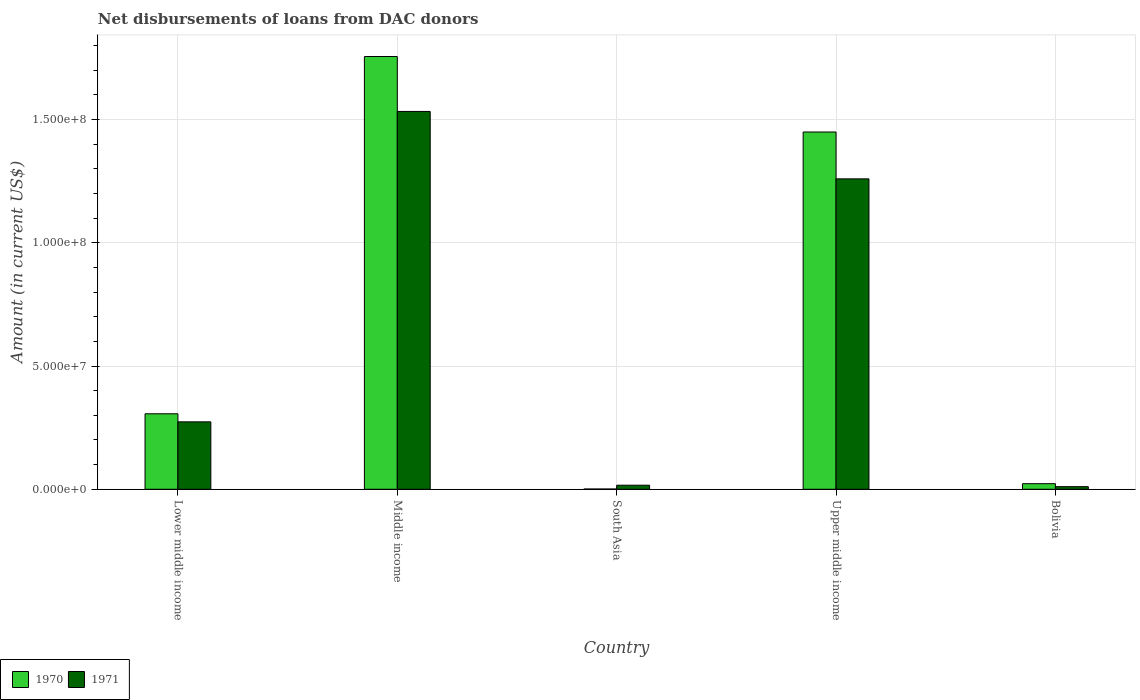How many different coloured bars are there?
Offer a terse response. 2. How many groups of bars are there?
Provide a succinct answer. 5. Are the number of bars per tick equal to the number of legend labels?
Your answer should be very brief. Yes. Are the number of bars on each tick of the X-axis equal?
Keep it short and to the point. Yes. What is the label of the 3rd group of bars from the left?
Provide a succinct answer. South Asia. What is the amount of loans disbursed in 1971 in Upper middle income?
Offer a very short reply. 1.26e+08. Across all countries, what is the maximum amount of loans disbursed in 1970?
Your answer should be compact. 1.76e+08. Across all countries, what is the minimum amount of loans disbursed in 1971?
Offer a very short reply. 1.06e+06. In which country was the amount of loans disbursed in 1970 minimum?
Your answer should be compact. South Asia. What is the total amount of loans disbursed in 1971 in the graph?
Keep it short and to the point. 3.09e+08. What is the difference between the amount of loans disbursed in 1971 in Bolivia and that in South Asia?
Make the answer very short. -5.92e+05. What is the difference between the amount of loans disbursed in 1970 in Lower middle income and the amount of loans disbursed in 1971 in Bolivia?
Your response must be concise. 2.96e+07. What is the average amount of loans disbursed in 1970 per country?
Make the answer very short. 7.07e+07. What is the difference between the amount of loans disbursed of/in 1971 and amount of loans disbursed of/in 1970 in Upper middle income?
Your answer should be compact. -1.90e+07. What is the ratio of the amount of loans disbursed in 1970 in Lower middle income to that in Upper middle income?
Provide a short and direct response. 0.21. Is the amount of loans disbursed in 1970 in Bolivia less than that in South Asia?
Your answer should be very brief. No. Is the difference between the amount of loans disbursed in 1971 in Middle income and South Asia greater than the difference between the amount of loans disbursed in 1970 in Middle income and South Asia?
Give a very brief answer. No. What is the difference between the highest and the second highest amount of loans disbursed in 1971?
Your answer should be very brief. 1.26e+08. What is the difference between the highest and the lowest amount of loans disbursed in 1970?
Your response must be concise. 1.75e+08. In how many countries, is the amount of loans disbursed in 1971 greater than the average amount of loans disbursed in 1971 taken over all countries?
Offer a very short reply. 2. What does the 2nd bar from the right in Middle income represents?
Your response must be concise. 1970. How many bars are there?
Your answer should be compact. 10. What is the difference between two consecutive major ticks on the Y-axis?
Your response must be concise. 5.00e+07. Does the graph contain any zero values?
Keep it short and to the point. No. Does the graph contain grids?
Provide a succinct answer. Yes. How many legend labels are there?
Give a very brief answer. 2. How are the legend labels stacked?
Provide a short and direct response. Horizontal. What is the title of the graph?
Make the answer very short. Net disbursements of loans from DAC donors. What is the label or title of the Y-axis?
Ensure brevity in your answer.  Amount (in current US$). What is the Amount (in current US$) of 1970 in Lower middle income?
Your response must be concise. 3.06e+07. What is the Amount (in current US$) in 1971 in Lower middle income?
Your response must be concise. 2.74e+07. What is the Amount (in current US$) of 1970 in Middle income?
Ensure brevity in your answer.  1.76e+08. What is the Amount (in current US$) of 1971 in Middle income?
Keep it short and to the point. 1.53e+08. What is the Amount (in current US$) of 1970 in South Asia?
Provide a succinct answer. 1.09e+05. What is the Amount (in current US$) of 1971 in South Asia?
Give a very brief answer. 1.65e+06. What is the Amount (in current US$) in 1970 in Upper middle income?
Provide a short and direct response. 1.45e+08. What is the Amount (in current US$) in 1971 in Upper middle income?
Give a very brief answer. 1.26e+08. What is the Amount (in current US$) in 1970 in Bolivia?
Provide a short and direct response. 2.27e+06. What is the Amount (in current US$) in 1971 in Bolivia?
Make the answer very short. 1.06e+06. Across all countries, what is the maximum Amount (in current US$) in 1970?
Offer a very short reply. 1.76e+08. Across all countries, what is the maximum Amount (in current US$) of 1971?
Your answer should be compact. 1.53e+08. Across all countries, what is the minimum Amount (in current US$) in 1970?
Provide a succinct answer. 1.09e+05. Across all countries, what is the minimum Amount (in current US$) in 1971?
Provide a succinct answer. 1.06e+06. What is the total Amount (in current US$) of 1970 in the graph?
Offer a terse response. 3.53e+08. What is the total Amount (in current US$) in 1971 in the graph?
Offer a terse response. 3.09e+08. What is the difference between the Amount (in current US$) of 1970 in Lower middle income and that in Middle income?
Provide a succinct answer. -1.45e+08. What is the difference between the Amount (in current US$) in 1971 in Lower middle income and that in Middle income?
Make the answer very short. -1.26e+08. What is the difference between the Amount (in current US$) in 1970 in Lower middle income and that in South Asia?
Offer a terse response. 3.05e+07. What is the difference between the Amount (in current US$) of 1971 in Lower middle income and that in South Asia?
Your answer should be compact. 2.57e+07. What is the difference between the Amount (in current US$) of 1970 in Lower middle income and that in Upper middle income?
Give a very brief answer. -1.14e+08. What is the difference between the Amount (in current US$) of 1971 in Lower middle income and that in Upper middle income?
Offer a very short reply. -9.86e+07. What is the difference between the Amount (in current US$) in 1970 in Lower middle income and that in Bolivia?
Offer a very short reply. 2.84e+07. What is the difference between the Amount (in current US$) in 1971 in Lower middle income and that in Bolivia?
Your answer should be very brief. 2.63e+07. What is the difference between the Amount (in current US$) of 1970 in Middle income and that in South Asia?
Ensure brevity in your answer.  1.75e+08. What is the difference between the Amount (in current US$) of 1971 in Middle income and that in South Asia?
Offer a very short reply. 1.52e+08. What is the difference between the Amount (in current US$) in 1970 in Middle income and that in Upper middle income?
Provide a short and direct response. 3.06e+07. What is the difference between the Amount (in current US$) in 1971 in Middle income and that in Upper middle income?
Your response must be concise. 2.74e+07. What is the difference between the Amount (in current US$) in 1970 in Middle income and that in Bolivia?
Keep it short and to the point. 1.73e+08. What is the difference between the Amount (in current US$) of 1971 in Middle income and that in Bolivia?
Provide a succinct answer. 1.52e+08. What is the difference between the Amount (in current US$) in 1970 in South Asia and that in Upper middle income?
Provide a succinct answer. -1.45e+08. What is the difference between the Amount (in current US$) in 1971 in South Asia and that in Upper middle income?
Give a very brief answer. -1.24e+08. What is the difference between the Amount (in current US$) in 1970 in South Asia and that in Bolivia?
Your response must be concise. -2.16e+06. What is the difference between the Amount (in current US$) in 1971 in South Asia and that in Bolivia?
Your answer should be very brief. 5.92e+05. What is the difference between the Amount (in current US$) of 1970 in Upper middle income and that in Bolivia?
Your response must be concise. 1.43e+08. What is the difference between the Amount (in current US$) in 1971 in Upper middle income and that in Bolivia?
Offer a very short reply. 1.25e+08. What is the difference between the Amount (in current US$) of 1970 in Lower middle income and the Amount (in current US$) of 1971 in Middle income?
Offer a very short reply. -1.23e+08. What is the difference between the Amount (in current US$) in 1970 in Lower middle income and the Amount (in current US$) in 1971 in South Asia?
Your response must be concise. 2.90e+07. What is the difference between the Amount (in current US$) of 1970 in Lower middle income and the Amount (in current US$) of 1971 in Upper middle income?
Keep it short and to the point. -9.53e+07. What is the difference between the Amount (in current US$) of 1970 in Lower middle income and the Amount (in current US$) of 1971 in Bolivia?
Provide a succinct answer. 2.96e+07. What is the difference between the Amount (in current US$) in 1970 in Middle income and the Amount (in current US$) in 1971 in South Asia?
Give a very brief answer. 1.74e+08. What is the difference between the Amount (in current US$) of 1970 in Middle income and the Amount (in current US$) of 1971 in Upper middle income?
Ensure brevity in your answer.  4.96e+07. What is the difference between the Amount (in current US$) in 1970 in Middle income and the Amount (in current US$) in 1971 in Bolivia?
Your answer should be very brief. 1.74e+08. What is the difference between the Amount (in current US$) of 1970 in South Asia and the Amount (in current US$) of 1971 in Upper middle income?
Your response must be concise. -1.26e+08. What is the difference between the Amount (in current US$) of 1970 in South Asia and the Amount (in current US$) of 1971 in Bolivia?
Provide a succinct answer. -9.49e+05. What is the difference between the Amount (in current US$) in 1970 in Upper middle income and the Amount (in current US$) in 1971 in Bolivia?
Offer a terse response. 1.44e+08. What is the average Amount (in current US$) of 1970 per country?
Keep it short and to the point. 7.07e+07. What is the average Amount (in current US$) of 1971 per country?
Provide a short and direct response. 6.19e+07. What is the difference between the Amount (in current US$) in 1970 and Amount (in current US$) in 1971 in Lower middle income?
Give a very brief answer. 3.27e+06. What is the difference between the Amount (in current US$) in 1970 and Amount (in current US$) in 1971 in Middle income?
Ensure brevity in your answer.  2.23e+07. What is the difference between the Amount (in current US$) of 1970 and Amount (in current US$) of 1971 in South Asia?
Provide a succinct answer. -1.54e+06. What is the difference between the Amount (in current US$) in 1970 and Amount (in current US$) in 1971 in Upper middle income?
Provide a succinct answer. 1.90e+07. What is the difference between the Amount (in current US$) in 1970 and Amount (in current US$) in 1971 in Bolivia?
Provide a succinct answer. 1.21e+06. What is the ratio of the Amount (in current US$) in 1970 in Lower middle income to that in Middle income?
Give a very brief answer. 0.17. What is the ratio of the Amount (in current US$) in 1971 in Lower middle income to that in Middle income?
Ensure brevity in your answer.  0.18. What is the ratio of the Amount (in current US$) of 1970 in Lower middle income to that in South Asia?
Offer a terse response. 280.94. What is the ratio of the Amount (in current US$) of 1971 in Lower middle income to that in South Asia?
Your answer should be compact. 16.58. What is the ratio of the Amount (in current US$) of 1970 in Lower middle income to that in Upper middle income?
Provide a short and direct response. 0.21. What is the ratio of the Amount (in current US$) in 1971 in Lower middle income to that in Upper middle income?
Keep it short and to the point. 0.22. What is the ratio of the Amount (in current US$) of 1970 in Lower middle income to that in Bolivia?
Your response must be concise. 13.49. What is the ratio of the Amount (in current US$) in 1971 in Lower middle income to that in Bolivia?
Provide a short and direct response. 25.85. What is the ratio of the Amount (in current US$) of 1970 in Middle income to that in South Asia?
Give a very brief answer. 1610.58. What is the ratio of the Amount (in current US$) of 1971 in Middle income to that in South Asia?
Provide a short and direct response. 92.89. What is the ratio of the Amount (in current US$) of 1970 in Middle income to that in Upper middle income?
Give a very brief answer. 1.21. What is the ratio of the Amount (in current US$) of 1971 in Middle income to that in Upper middle income?
Keep it short and to the point. 1.22. What is the ratio of the Amount (in current US$) in 1970 in Middle income to that in Bolivia?
Your answer should be very brief. 77.34. What is the ratio of the Amount (in current US$) in 1971 in Middle income to that in Bolivia?
Your answer should be compact. 144.87. What is the ratio of the Amount (in current US$) of 1970 in South Asia to that in Upper middle income?
Provide a succinct answer. 0. What is the ratio of the Amount (in current US$) of 1971 in South Asia to that in Upper middle income?
Your answer should be very brief. 0.01. What is the ratio of the Amount (in current US$) of 1970 in South Asia to that in Bolivia?
Your response must be concise. 0.05. What is the ratio of the Amount (in current US$) in 1971 in South Asia to that in Bolivia?
Provide a succinct answer. 1.56. What is the ratio of the Amount (in current US$) in 1970 in Upper middle income to that in Bolivia?
Make the answer very short. 63.85. What is the ratio of the Amount (in current US$) of 1971 in Upper middle income to that in Bolivia?
Keep it short and to the point. 119.02. What is the difference between the highest and the second highest Amount (in current US$) of 1970?
Make the answer very short. 3.06e+07. What is the difference between the highest and the second highest Amount (in current US$) in 1971?
Ensure brevity in your answer.  2.74e+07. What is the difference between the highest and the lowest Amount (in current US$) in 1970?
Keep it short and to the point. 1.75e+08. What is the difference between the highest and the lowest Amount (in current US$) of 1971?
Provide a succinct answer. 1.52e+08. 